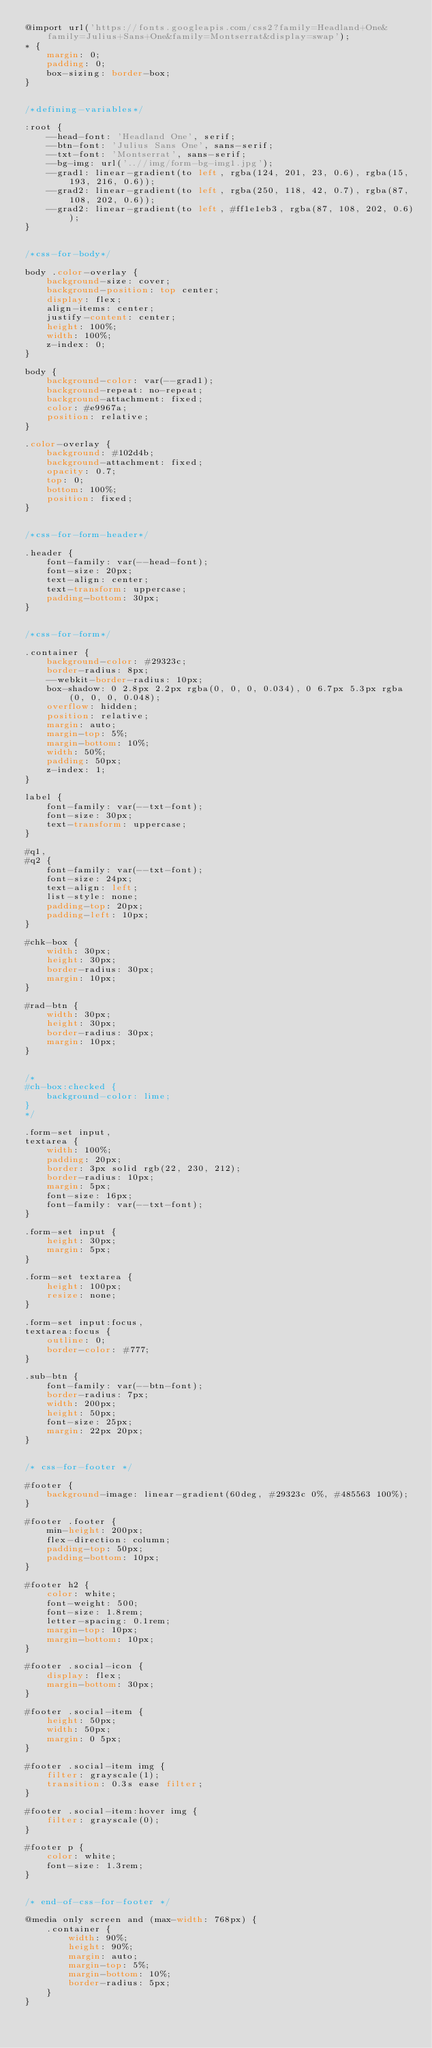Convert code to text. <code><loc_0><loc_0><loc_500><loc_500><_CSS_>@import url('https://fonts.googleapis.com/css2?family=Headland+One&family=Julius+Sans+One&family=Montserrat&display=swap');
* {
    margin: 0;
    padding: 0;
    box-sizing: border-box;
}


/*defining-variables*/

:root {
    --head-font: 'Headland One', serif;
    --btn-font: 'Julius Sans One', sans-serif;
    --txt-font: 'Montserrat', sans-serif;
    --bg-img: url('..//img/form-bg-img1.jpg');
    --grad1: linear-gradient(to left, rgba(124, 201, 23, 0.6), rgba(15, 193, 216, 0.6));
    --grad2: linear-gradient(to left, rgba(250, 118, 42, 0.7), rgba(87, 108, 202, 0.6));
    --grad2: linear-gradient(to left, #ff1e1eb3, rgba(87, 108, 202, 0.6));
}


/*css-for-body*/

body .color-overlay {
    background-size: cover;
    background-position: top center;
    display: flex;
    align-items: center;
    justify-content: center;
    height: 100%;
    width: 100%;
    z-index: 0;
}

body {
    background-color: var(--grad1);
    background-repeat: no-repeat;
    background-attachment: fixed;
    color: #e9967a;
    position: relative;
}

.color-overlay {
    background: #102d4b;
    background-attachment: fixed;
    opacity: 0.7;
    top: 0;
    bottom: 100%;
    position: fixed;
}


/*css-for-form-header*/

.header {
    font-family: var(--head-font);
    font-size: 20px;
    text-align: center;
    text-transform: uppercase;
    padding-bottom: 30px;
}


/*css-for-form*/

.container {
    background-color: #29323c;
    border-radius: 8px;
    --webkit-border-radius: 10px;
    box-shadow: 0 2.8px 2.2px rgba(0, 0, 0, 0.034), 0 6.7px 5.3px rgba(0, 0, 0, 0.048);
    overflow: hidden;
    position: relative;
    margin: auto;
    margin-top: 5%;
    margin-bottom: 10%;
    width: 50%;
    padding: 50px;
    z-index: 1;
}

label {
    font-family: var(--txt-font);
    font-size: 30px;
    text-transform: uppercase;
}

#q1,
#q2 {
    font-family: var(--txt-font);
    font-size: 24px;
    text-align: left;
    list-style: none;
    padding-top: 20px;
    padding-left: 10px;
}

#chk-box {
    width: 30px;
    height: 30px;
    border-radius: 30px;
    margin: 10px;
}

#rad-btn {
    width: 30px;
    height: 30px;
    border-radius: 30px;
    margin: 10px;
}


/*
#ch-box:checked {
    background-color: lime;
}
*/

.form-set input,
textarea {
    width: 100%;
    padding: 20px;
    border: 3px solid rgb(22, 230, 212);
    border-radius: 10px;
    margin: 5px;
    font-size: 16px;
    font-family: var(--txt-font);
}

.form-set input {
    height: 30px;
    margin: 5px;
}

.form-set textarea {
    height: 100px;
    resize: none;
}

.form-set input:focus,
textarea:focus {
    outline: 0;
    border-color: #777;
}

.sub-btn {
    font-family: var(--btn-font);
    border-radius: 7px;
    width: 200px;
    height: 50px;
    font-size: 25px;
    margin: 22px 20px;
}


/* css-for-footer */

#footer {
    background-image: linear-gradient(60deg, #29323c 0%, #485563 100%);
}

#footer .footer {
    min-height: 200px;
    flex-direction: column;
    padding-top: 50px;
    padding-bottom: 10px;
}

#footer h2 {
    color: white;
    font-weight: 500;
    font-size: 1.8rem;
    letter-spacing: 0.1rem;
    margin-top: 10px;
    margin-bottom: 10px;
}

#footer .social-icon {
    display: flex;
    margin-bottom: 30px;
}

#footer .social-item {
    height: 50px;
    width: 50px;
    margin: 0 5px;
}

#footer .social-item img {
    filter: grayscale(1);
    transition: 0.3s ease filter;
}

#footer .social-item:hover img {
    filter: grayscale(0);
}

#footer p {
    color: white;
    font-size: 1.3rem;
}


/* end-of-css-for-footer */

@media only screen and (max-width: 768px) {
    .container {
        width: 90%;
        height: 90%;
        margin: auto;
        margin-top: 5%;
        margin-bottom: 10%;
        border-radius: 5px;
    }
}</code> 